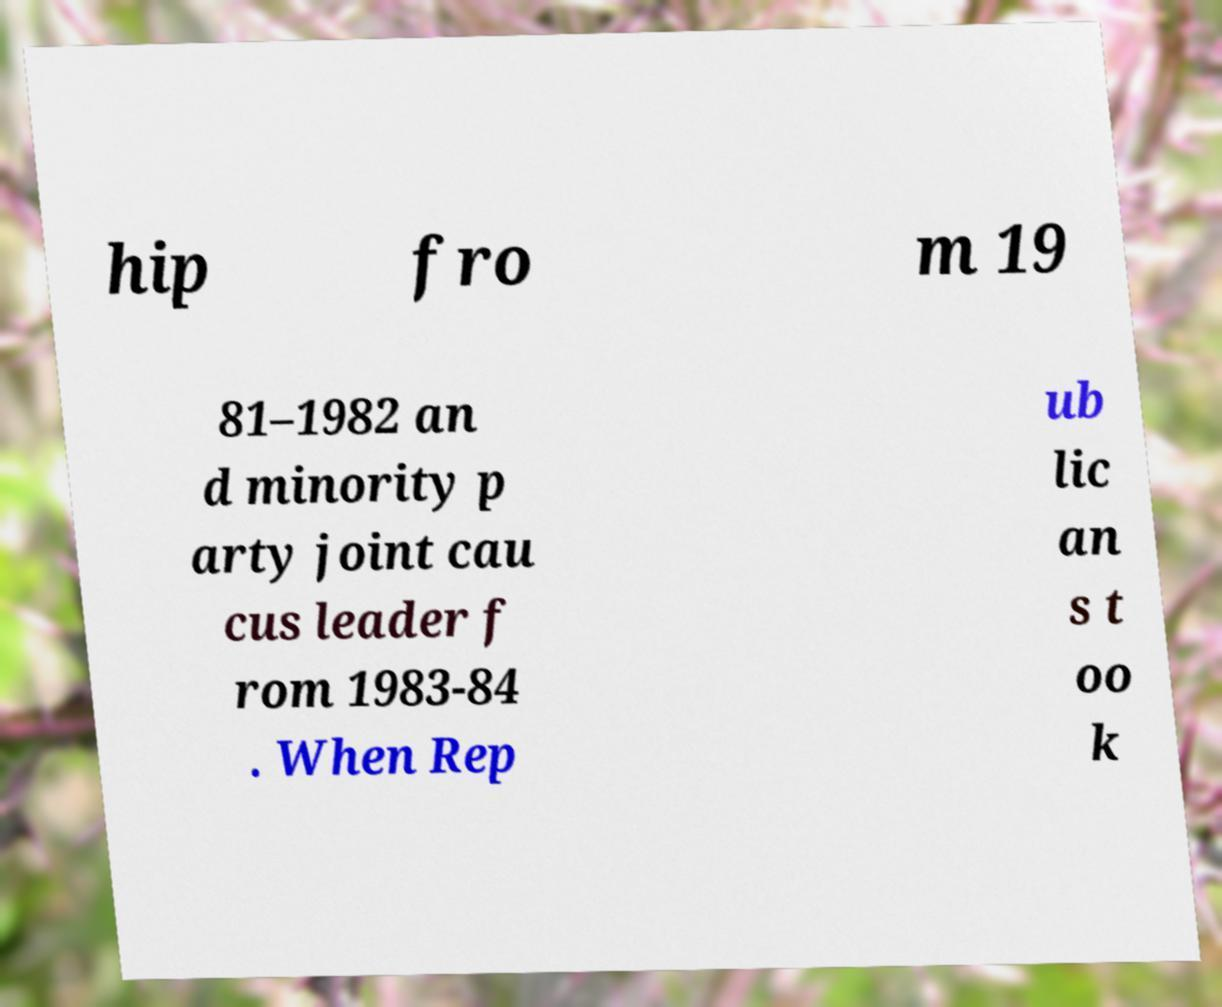What messages or text are displayed in this image? I need them in a readable, typed format. hip fro m 19 81–1982 an d minority p arty joint cau cus leader f rom 1983-84 . When Rep ub lic an s t oo k 